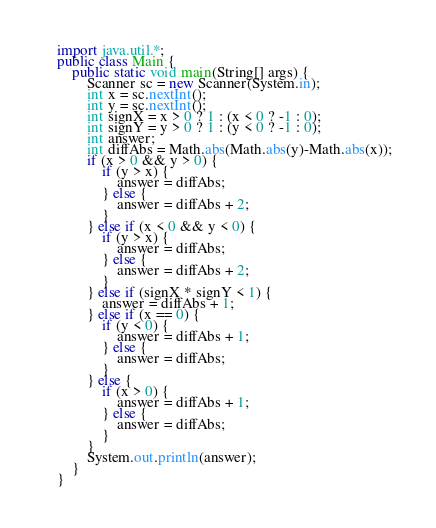Convert code to text. <code><loc_0><loc_0><loc_500><loc_500><_Java_>import java.util.*;
public class Main {
    public static void main(String[] args) {
        Scanner sc = new Scanner(System.in);
        int x = sc.nextInt();
        int y = sc.nextInt();
        int signX = x > 0 ? 1 : (x < 0 ? -1 : 0);
        int signY = y > 0 ? 1 : (y < 0 ? -1 : 0);
        int answer;
        int diffAbs = Math.abs(Math.abs(y)-Math.abs(x));
        if (x > 0 && y > 0) {
            if (y > x) {
                answer = diffAbs;
            } else {
                answer = diffAbs + 2;
            }
        } else if (x < 0 && y < 0) {
            if (y > x) {
                answer = diffAbs;
            } else {
                answer = diffAbs + 2;
            }
        } else if (signX * signY < 1) {
            answer = diffAbs + 1;
        } else if (x == 0) {
            if (y < 0) {
                answer = diffAbs + 1;
            } else {
                answer = diffAbs;
            }
        } else {
            if (x > 0) {
                answer = diffAbs + 1;
            } else {
                answer = diffAbs;
            }
        }
        System.out.println(answer);
    }
}</code> 